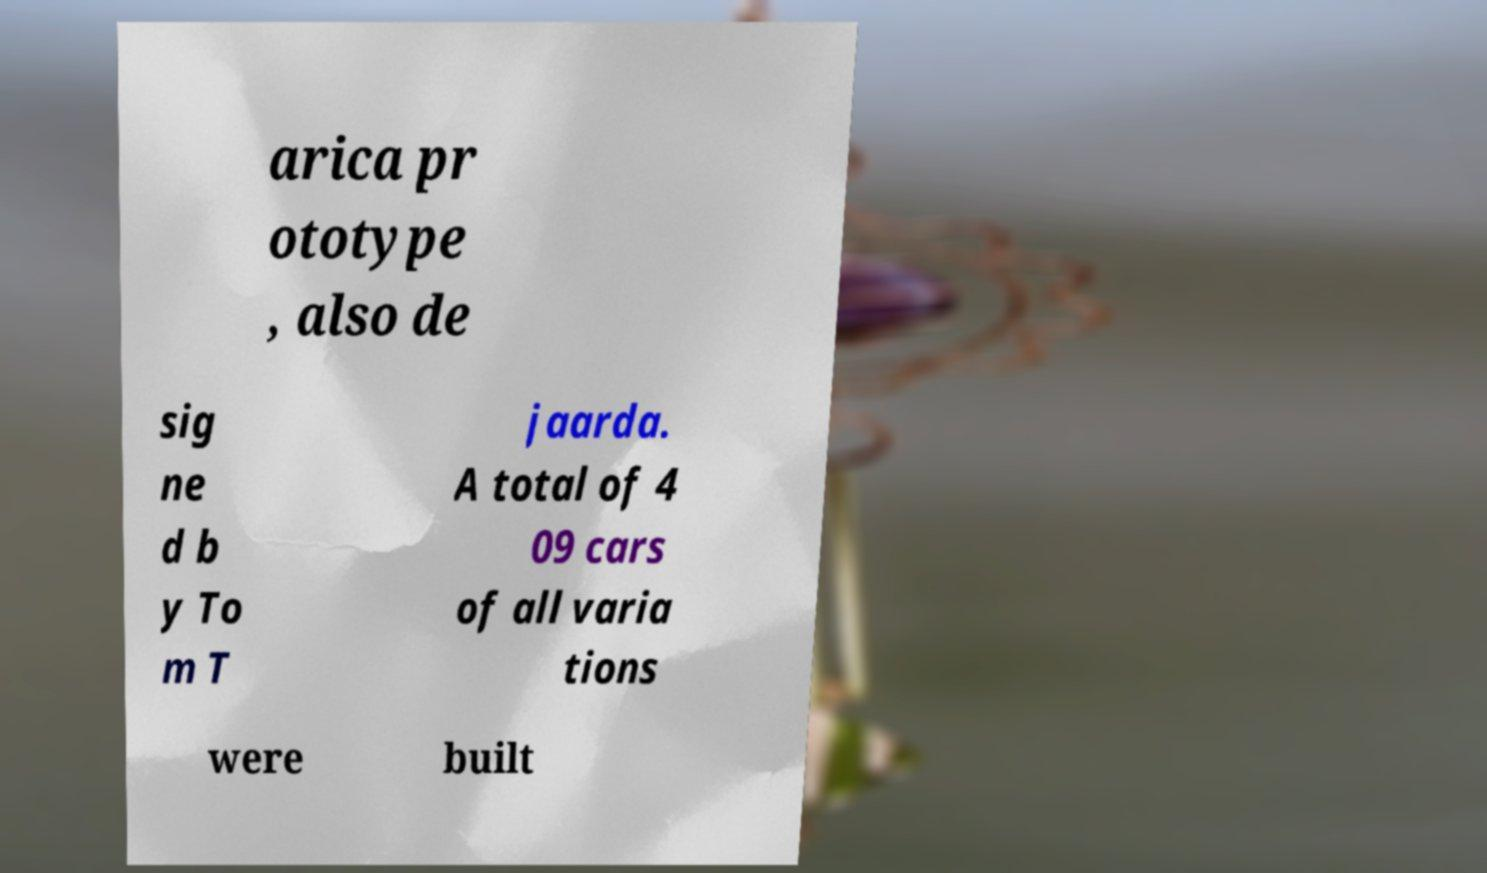There's text embedded in this image that I need extracted. Can you transcribe it verbatim? arica pr ototype , also de sig ne d b y To m T jaarda. A total of 4 09 cars of all varia tions were built 